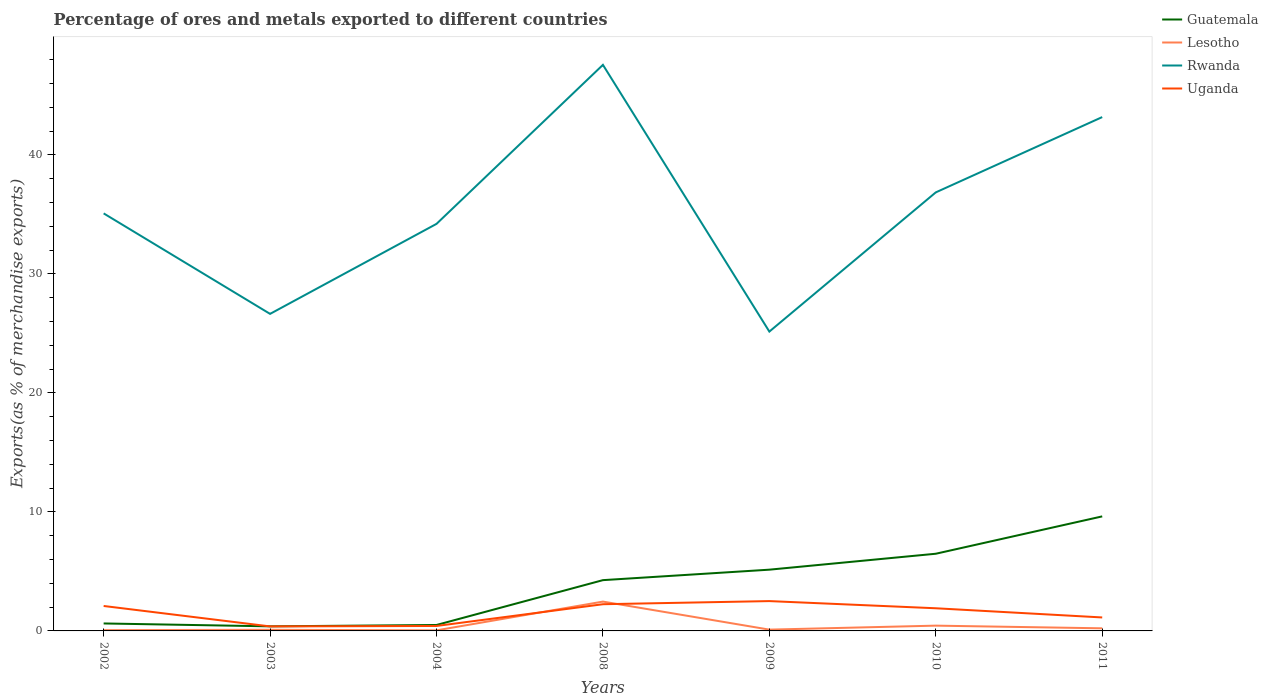Does the line corresponding to Rwanda intersect with the line corresponding to Guatemala?
Make the answer very short. No. Across all years, what is the maximum percentage of exports to different countries in Lesotho?
Offer a terse response. 0.05. In which year was the percentage of exports to different countries in Lesotho maximum?
Provide a succinct answer. 2004. What is the total percentage of exports to different countries in Lesotho in the graph?
Keep it short and to the point. -2.37. What is the difference between the highest and the second highest percentage of exports to different countries in Guatemala?
Your answer should be very brief. 9.24. What is the difference between the highest and the lowest percentage of exports to different countries in Rwanda?
Your answer should be compact. 3. Is the percentage of exports to different countries in Lesotho strictly greater than the percentage of exports to different countries in Guatemala over the years?
Your answer should be very brief. Yes. What is the difference between two consecutive major ticks on the Y-axis?
Offer a very short reply. 10. Are the values on the major ticks of Y-axis written in scientific E-notation?
Provide a succinct answer. No. How many legend labels are there?
Keep it short and to the point. 4. What is the title of the graph?
Make the answer very short. Percentage of ores and metals exported to different countries. What is the label or title of the Y-axis?
Offer a terse response. Exports(as % of merchandise exports). What is the Exports(as % of merchandise exports) in Guatemala in 2002?
Provide a succinct answer. 0.63. What is the Exports(as % of merchandise exports) of Lesotho in 2002?
Your response must be concise. 0.06. What is the Exports(as % of merchandise exports) of Rwanda in 2002?
Ensure brevity in your answer.  35.09. What is the Exports(as % of merchandise exports) of Uganda in 2002?
Give a very brief answer. 2.1. What is the Exports(as % of merchandise exports) in Guatemala in 2003?
Your answer should be very brief. 0.39. What is the Exports(as % of merchandise exports) in Lesotho in 2003?
Provide a succinct answer. 0.1. What is the Exports(as % of merchandise exports) in Rwanda in 2003?
Your answer should be very brief. 26.64. What is the Exports(as % of merchandise exports) in Uganda in 2003?
Give a very brief answer. 0.38. What is the Exports(as % of merchandise exports) of Guatemala in 2004?
Provide a succinct answer. 0.5. What is the Exports(as % of merchandise exports) in Lesotho in 2004?
Give a very brief answer. 0.05. What is the Exports(as % of merchandise exports) of Rwanda in 2004?
Give a very brief answer. 34.21. What is the Exports(as % of merchandise exports) of Uganda in 2004?
Your answer should be very brief. 0.42. What is the Exports(as % of merchandise exports) in Guatemala in 2008?
Your answer should be compact. 4.27. What is the Exports(as % of merchandise exports) in Lesotho in 2008?
Offer a terse response. 2.47. What is the Exports(as % of merchandise exports) of Rwanda in 2008?
Keep it short and to the point. 47.57. What is the Exports(as % of merchandise exports) of Uganda in 2008?
Provide a succinct answer. 2.24. What is the Exports(as % of merchandise exports) of Guatemala in 2009?
Provide a short and direct response. 5.15. What is the Exports(as % of merchandise exports) in Lesotho in 2009?
Provide a short and direct response. 0.11. What is the Exports(as % of merchandise exports) in Rwanda in 2009?
Offer a terse response. 25.16. What is the Exports(as % of merchandise exports) in Uganda in 2009?
Ensure brevity in your answer.  2.51. What is the Exports(as % of merchandise exports) in Guatemala in 2010?
Give a very brief answer. 6.49. What is the Exports(as % of merchandise exports) of Lesotho in 2010?
Your response must be concise. 0.44. What is the Exports(as % of merchandise exports) in Rwanda in 2010?
Your answer should be compact. 36.85. What is the Exports(as % of merchandise exports) in Uganda in 2010?
Ensure brevity in your answer.  1.9. What is the Exports(as % of merchandise exports) of Guatemala in 2011?
Give a very brief answer. 9.63. What is the Exports(as % of merchandise exports) of Lesotho in 2011?
Provide a succinct answer. 0.22. What is the Exports(as % of merchandise exports) in Rwanda in 2011?
Keep it short and to the point. 43.18. What is the Exports(as % of merchandise exports) of Uganda in 2011?
Make the answer very short. 1.13. Across all years, what is the maximum Exports(as % of merchandise exports) in Guatemala?
Your answer should be very brief. 9.63. Across all years, what is the maximum Exports(as % of merchandise exports) of Lesotho?
Provide a short and direct response. 2.47. Across all years, what is the maximum Exports(as % of merchandise exports) in Rwanda?
Offer a very short reply. 47.57. Across all years, what is the maximum Exports(as % of merchandise exports) in Uganda?
Make the answer very short. 2.51. Across all years, what is the minimum Exports(as % of merchandise exports) in Guatemala?
Your answer should be very brief. 0.39. Across all years, what is the minimum Exports(as % of merchandise exports) of Lesotho?
Provide a succinct answer. 0.05. Across all years, what is the minimum Exports(as % of merchandise exports) in Rwanda?
Provide a succinct answer. 25.16. Across all years, what is the minimum Exports(as % of merchandise exports) in Uganda?
Provide a succinct answer. 0.38. What is the total Exports(as % of merchandise exports) of Guatemala in the graph?
Make the answer very short. 27.04. What is the total Exports(as % of merchandise exports) of Lesotho in the graph?
Ensure brevity in your answer.  3.44. What is the total Exports(as % of merchandise exports) of Rwanda in the graph?
Your answer should be very brief. 248.7. What is the total Exports(as % of merchandise exports) of Uganda in the graph?
Your answer should be very brief. 10.68. What is the difference between the Exports(as % of merchandise exports) in Guatemala in 2002 and that in 2003?
Offer a very short reply. 0.24. What is the difference between the Exports(as % of merchandise exports) of Lesotho in 2002 and that in 2003?
Make the answer very short. -0.03. What is the difference between the Exports(as % of merchandise exports) in Rwanda in 2002 and that in 2003?
Your response must be concise. 8.45. What is the difference between the Exports(as % of merchandise exports) in Uganda in 2002 and that in 2003?
Offer a very short reply. 1.72. What is the difference between the Exports(as % of merchandise exports) of Guatemala in 2002 and that in 2004?
Make the answer very short. 0.13. What is the difference between the Exports(as % of merchandise exports) in Lesotho in 2002 and that in 2004?
Your response must be concise. 0.02. What is the difference between the Exports(as % of merchandise exports) in Rwanda in 2002 and that in 2004?
Provide a succinct answer. 0.88. What is the difference between the Exports(as % of merchandise exports) of Uganda in 2002 and that in 2004?
Make the answer very short. 1.68. What is the difference between the Exports(as % of merchandise exports) in Guatemala in 2002 and that in 2008?
Your answer should be compact. -3.64. What is the difference between the Exports(as % of merchandise exports) of Lesotho in 2002 and that in 2008?
Give a very brief answer. -2.4. What is the difference between the Exports(as % of merchandise exports) in Rwanda in 2002 and that in 2008?
Your response must be concise. -12.48. What is the difference between the Exports(as % of merchandise exports) of Uganda in 2002 and that in 2008?
Ensure brevity in your answer.  -0.15. What is the difference between the Exports(as % of merchandise exports) in Guatemala in 2002 and that in 2009?
Your answer should be compact. -4.52. What is the difference between the Exports(as % of merchandise exports) in Lesotho in 2002 and that in 2009?
Your answer should be compact. -0.04. What is the difference between the Exports(as % of merchandise exports) of Rwanda in 2002 and that in 2009?
Offer a terse response. 9.93. What is the difference between the Exports(as % of merchandise exports) in Uganda in 2002 and that in 2009?
Your answer should be compact. -0.41. What is the difference between the Exports(as % of merchandise exports) in Guatemala in 2002 and that in 2010?
Ensure brevity in your answer.  -5.86. What is the difference between the Exports(as % of merchandise exports) of Lesotho in 2002 and that in 2010?
Your answer should be very brief. -0.38. What is the difference between the Exports(as % of merchandise exports) of Rwanda in 2002 and that in 2010?
Your answer should be compact. -1.77. What is the difference between the Exports(as % of merchandise exports) of Uganda in 2002 and that in 2010?
Your response must be concise. 0.19. What is the difference between the Exports(as % of merchandise exports) of Guatemala in 2002 and that in 2011?
Offer a very short reply. -9. What is the difference between the Exports(as % of merchandise exports) of Lesotho in 2002 and that in 2011?
Ensure brevity in your answer.  -0.15. What is the difference between the Exports(as % of merchandise exports) of Rwanda in 2002 and that in 2011?
Ensure brevity in your answer.  -8.09. What is the difference between the Exports(as % of merchandise exports) in Uganda in 2002 and that in 2011?
Ensure brevity in your answer.  0.96. What is the difference between the Exports(as % of merchandise exports) in Guatemala in 2003 and that in 2004?
Your response must be concise. -0.11. What is the difference between the Exports(as % of merchandise exports) in Lesotho in 2003 and that in 2004?
Give a very brief answer. 0.05. What is the difference between the Exports(as % of merchandise exports) in Rwanda in 2003 and that in 2004?
Give a very brief answer. -7.56. What is the difference between the Exports(as % of merchandise exports) in Uganda in 2003 and that in 2004?
Your answer should be very brief. -0.04. What is the difference between the Exports(as % of merchandise exports) of Guatemala in 2003 and that in 2008?
Ensure brevity in your answer.  -3.88. What is the difference between the Exports(as % of merchandise exports) in Lesotho in 2003 and that in 2008?
Offer a terse response. -2.37. What is the difference between the Exports(as % of merchandise exports) of Rwanda in 2003 and that in 2008?
Provide a succinct answer. -20.93. What is the difference between the Exports(as % of merchandise exports) of Uganda in 2003 and that in 2008?
Your answer should be compact. -1.86. What is the difference between the Exports(as % of merchandise exports) of Guatemala in 2003 and that in 2009?
Your answer should be compact. -4.76. What is the difference between the Exports(as % of merchandise exports) of Lesotho in 2003 and that in 2009?
Provide a short and direct response. -0.01. What is the difference between the Exports(as % of merchandise exports) of Rwanda in 2003 and that in 2009?
Keep it short and to the point. 1.49. What is the difference between the Exports(as % of merchandise exports) in Uganda in 2003 and that in 2009?
Make the answer very short. -2.13. What is the difference between the Exports(as % of merchandise exports) in Guatemala in 2003 and that in 2010?
Your answer should be very brief. -6.1. What is the difference between the Exports(as % of merchandise exports) in Lesotho in 2003 and that in 2010?
Your answer should be very brief. -0.35. What is the difference between the Exports(as % of merchandise exports) in Rwanda in 2003 and that in 2010?
Provide a succinct answer. -10.21. What is the difference between the Exports(as % of merchandise exports) in Uganda in 2003 and that in 2010?
Offer a very short reply. -1.52. What is the difference between the Exports(as % of merchandise exports) in Guatemala in 2003 and that in 2011?
Offer a very short reply. -9.24. What is the difference between the Exports(as % of merchandise exports) of Lesotho in 2003 and that in 2011?
Your answer should be compact. -0.12. What is the difference between the Exports(as % of merchandise exports) of Rwanda in 2003 and that in 2011?
Ensure brevity in your answer.  -16.54. What is the difference between the Exports(as % of merchandise exports) of Uganda in 2003 and that in 2011?
Provide a short and direct response. -0.75. What is the difference between the Exports(as % of merchandise exports) in Guatemala in 2004 and that in 2008?
Provide a succinct answer. -3.77. What is the difference between the Exports(as % of merchandise exports) in Lesotho in 2004 and that in 2008?
Your answer should be very brief. -2.42. What is the difference between the Exports(as % of merchandise exports) of Rwanda in 2004 and that in 2008?
Your answer should be very brief. -13.36. What is the difference between the Exports(as % of merchandise exports) in Uganda in 2004 and that in 2008?
Your answer should be compact. -1.83. What is the difference between the Exports(as % of merchandise exports) in Guatemala in 2004 and that in 2009?
Your answer should be very brief. -4.65. What is the difference between the Exports(as % of merchandise exports) in Lesotho in 2004 and that in 2009?
Offer a terse response. -0.06. What is the difference between the Exports(as % of merchandise exports) in Rwanda in 2004 and that in 2009?
Provide a short and direct response. 9.05. What is the difference between the Exports(as % of merchandise exports) in Uganda in 2004 and that in 2009?
Provide a short and direct response. -2.09. What is the difference between the Exports(as % of merchandise exports) of Guatemala in 2004 and that in 2010?
Provide a succinct answer. -5.99. What is the difference between the Exports(as % of merchandise exports) in Lesotho in 2004 and that in 2010?
Your answer should be very brief. -0.4. What is the difference between the Exports(as % of merchandise exports) of Rwanda in 2004 and that in 2010?
Offer a terse response. -2.65. What is the difference between the Exports(as % of merchandise exports) in Uganda in 2004 and that in 2010?
Provide a short and direct response. -1.49. What is the difference between the Exports(as % of merchandise exports) of Guatemala in 2004 and that in 2011?
Ensure brevity in your answer.  -9.13. What is the difference between the Exports(as % of merchandise exports) in Lesotho in 2004 and that in 2011?
Make the answer very short. -0.17. What is the difference between the Exports(as % of merchandise exports) in Rwanda in 2004 and that in 2011?
Provide a succinct answer. -8.98. What is the difference between the Exports(as % of merchandise exports) of Uganda in 2004 and that in 2011?
Provide a succinct answer. -0.72. What is the difference between the Exports(as % of merchandise exports) of Guatemala in 2008 and that in 2009?
Your response must be concise. -0.88. What is the difference between the Exports(as % of merchandise exports) of Lesotho in 2008 and that in 2009?
Offer a very short reply. 2.36. What is the difference between the Exports(as % of merchandise exports) in Rwanda in 2008 and that in 2009?
Your answer should be compact. 22.41. What is the difference between the Exports(as % of merchandise exports) in Uganda in 2008 and that in 2009?
Your answer should be very brief. -0.26. What is the difference between the Exports(as % of merchandise exports) in Guatemala in 2008 and that in 2010?
Provide a short and direct response. -2.22. What is the difference between the Exports(as % of merchandise exports) of Lesotho in 2008 and that in 2010?
Make the answer very short. 2.02. What is the difference between the Exports(as % of merchandise exports) in Rwanda in 2008 and that in 2010?
Your answer should be compact. 10.72. What is the difference between the Exports(as % of merchandise exports) in Uganda in 2008 and that in 2010?
Keep it short and to the point. 0.34. What is the difference between the Exports(as % of merchandise exports) in Guatemala in 2008 and that in 2011?
Offer a terse response. -5.36. What is the difference between the Exports(as % of merchandise exports) of Lesotho in 2008 and that in 2011?
Ensure brevity in your answer.  2.25. What is the difference between the Exports(as % of merchandise exports) of Rwanda in 2008 and that in 2011?
Provide a succinct answer. 4.39. What is the difference between the Exports(as % of merchandise exports) in Uganda in 2008 and that in 2011?
Keep it short and to the point. 1.11. What is the difference between the Exports(as % of merchandise exports) of Guatemala in 2009 and that in 2010?
Make the answer very short. -1.34. What is the difference between the Exports(as % of merchandise exports) in Lesotho in 2009 and that in 2010?
Your answer should be very brief. -0.33. What is the difference between the Exports(as % of merchandise exports) in Rwanda in 2009 and that in 2010?
Your answer should be compact. -11.7. What is the difference between the Exports(as % of merchandise exports) in Uganda in 2009 and that in 2010?
Provide a succinct answer. 0.6. What is the difference between the Exports(as % of merchandise exports) of Guatemala in 2009 and that in 2011?
Your answer should be very brief. -4.48. What is the difference between the Exports(as % of merchandise exports) in Lesotho in 2009 and that in 2011?
Your answer should be very brief. -0.11. What is the difference between the Exports(as % of merchandise exports) of Rwanda in 2009 and that in 2011?
Keep it short and to the point. -18.03. What is the difference between the Exports(as % of merchandise exports) of Uganda in 2009 and that in 2011?
Ensure brevity in your answer.  1.37. What is the difference between the Exports(as % of merchandise exports) of Guatemala in 2010 and that in 2011?
Offer a terse response. -3.14. What is the difference between the Exports(as % of merchandise exports) of Lesotho in 2010 and that in 2011?
Ensure brevity in your answer.  0.22. What is the difference between the Exports(as % of merchandise exports) in Rwanda in 2010 and that in 2011?
Offer a very short reply. -6.33. What is the difference between the Exports(as % of merchandise exports) in Uganda in 2010 and that in 2011?
Ensure brevity in your answer.  0.77. What is the difference between the Exports(as % of merchandise exports) of Guatemala in 2002 and the Exports(as % of merchandise exports) of Lesotho in 2003?
Ensure brevity in your answer.  0.53. What is the difference between the Exports(as % of merchandise exports) of Guatemala in 2002 and the Exports(as % of merchandise exports) of Rwanda in 2003?
Offer a terse response. -26.01. What is the difference between the Exports(as % of merchandise exports) of Guatemala in 2002 and the Exports(as % of merchandise exports) of Uganda in 2003?
Provide a short and direct response. 0.25. What is the difference between the Exports(as % of merchandise exports) in Lesotho in 2002 and the Exports(as % of merchandise exports) in Rwanda in 2003?
Ensure brevity in your answer.  -26.58. What is the difference between the Exports(as % of merchandise exports) in Lesotho in 2002 and the Exports(as % of merchandise exports) in Uganda in 2003?
Provide a short and direct response. -0.31. What is the difference between the Exports(as % of merchandise exports) in Rwanda in 2002 and the Exports(as % of merchandise exports) in Uganda in 2003?
Make the answer very short. 34.71. What is the difference between the Exports(as % of merchandise exports) of Guatemala in 2002 and the Exports(as % of merchandise exports) of Lesotho in 2004?
Give a very brief answer. 0.58. What is the difference between the Exports(as % of merchandise exports) of Guatemala in 2002 and the Exports(as % of merchandise exports) of Rwanda in 2004?
Provide a succinct answer. -33.58. What is the difference between the Exports(as % of merchandise exports) in Guatemala in 2002 and the Exports(as % of merchandise exports) in Uganda in 2004?
Keep it short and to the point. 0.21. What is the difference between the Exports(as % of merchandise exports) of Lesotho in 2002 and the Exports(as % of merchandise exports) of Rwanda in 2004?
Keep it short and to the point. -34.14. What is the difference between the Exports(as % of merchandise exports) of Lesotho in 2002 and the Exports(as % of merchandise exports) of Uganda in 2004?
Keep it short and to the point. -0.35. What is the difference between the Exports(as % of merchandise exports) of Rwanda in 2002 and the Exports(as % of merchandise exports) of Uganda in 2004?
Your response must be concise. 34.67. What is the difference between the Exports(as % of merchandise exports) in Guatemala in 2002 and the Exports(as % of merchandise exports) in Lesotho in 2008?
Your answer should be compact. -1.84. What is the difference between the Exports(as % of merchandise exports) of Guatemala in 2002 and the Exports(as % of merchandise exports) of Rwanda in 2008?
Make the answer very short. -46.94. What is the difference between the Exports(as % of merchandise exports) in Guatemala in 2002 and the Exports(as % of merchandise exports) in Uganda in 2008?
Your answer should be compact. -1.62. What is the difference between the Exports(as % of merchandise exports) in Lesotho in 2002 and the Exports(as % of merchandise exports) in Rwanda in 2008?
Your response must be concise. -47.51. What is the difference between the Exports(as % of merchandise exports) of Lesotho in 2002 and the Exports(as % of merchandise exports) of Uganda in 2008?
Give a very brief answer. -2.18. What is the difference between the Exports(as % of merchandise exports) in Rwanda in 2002 and the Exports(as % of merchandise exports) in Uganda in 2008?
Your response must be concise. 32.84. What is the difference between the Exports(as % of merchandise exports) of Guatemala in 2002 and the Exports(as % of merchandise exports) of Lesotho in 2009?
Ensure brevity in your answer.  0.52. What is the difference between the Exports(as % of merchandise exports) in Guatemala in 2002 and the Exports(as % of merchandise exports) in Rwanda in 2009?
Offer a terse response. -24.53. What is the difference between the Exports(as % of merchandise exports) in Guatemala in 2002 and the Exports(as % of merchandise exports) in Uganda in 2009?
Your answer should be compact. -1.88. What is the difference between the Exports(as % of merchandise exports) in Lesotho in 2002 and the Exports(as % of merchandise exports) in Rwanda in 2009?
Offer a very short reply. -25.09. What is the difference between the Exports(as % of merchandise exports) of Lesotho in 2002 and the Exports(as % of merchandise exports) of Uganda in 2009?
Provide a succinct answer. -2.44. What is the difference between the Exports(as % of merchandise exports) of Rwanda in 2002 and the Exports(as % of merchandise exports) of Uganda in 2009?
Provide a short and direct response. 32.58. What is the difference between the Exports(as % of merchandise exports) in Guatemala in 2002 and the Exports(as % of merchandise exports) in Lesotho in 2010?
Your answer should be very brief. 0.18. What is the difference between the Exports(as % of merchandise exports) in Guatemala in 2002 and the Exports(as % of merchandise exports) in Rwanda in 2010?
Make the answer very short. -36.23. What is the difference between the Exports(as % of merchandise exports) of Guatemala in 2002 and the Exports(as % of merchandise exports) of Uganda in 2010?
Your response must be concise. -1.28. What is the difference between the Exports(as % of merchandise exports) of Lesotho in 2002 and the Exports(as % of merchandise exports) of Rwanda in 2010?
Offer a very short reply. -36.79. What is the difference between the Exports(as % of merchandise exports) of Lesotho in 2002 and the Exports(as % of merchandise exports) of Uganda in 2010?
Your answer should be very brief. -1.84. What is the difference between the Exports(as % of merchandise exports) in Rwanda in 2002 and the Exports(as % of merchandise exports) in Uganda in 2010?
Offer a very short reply. 33.18. What is the difference between the Exports(as % of merchandise exports) of Guatemala in 2002 and the Exports(as % of merchandise exports) of Lesotho in 2011?
Provide a succinct answer. 0.41. What is the difference between the Exports(as % of merchandise exports) of Guatemala in 2002 and the Exports(as % of merchandise exports) of Rwanda in 2011?
Your answer should be very brief. -42.55. What is the difference between the Exports(as % of merchandise exports) of Guatemala in 2002 and the Exports(as % of merchandise exports) of Uganda in 2011?
Provide a short and direct response. -0.5. What is the difference between the Exports(as % of merchandise exports) of Lesotho in 2002 and the Exports(as % of merchandise exports) of Rwanda in 2011?
Your response must be concise. -43.12. What is the difference between the Exports(as % of merchandise exports) of Lesotho in 2002 and the Exports(as % of merchandise exports) of Uganda in 2011?
Ensure brevity in your answer.  -1.07. What is the difference between the Exports(as % of merchandise exports) of Rwanda in 2002 and the Exports(as % of merchandise exports) of Uganda in 2011?
Your answer should be very brief. 33.96. What is the difference between the Exports(as % of merchandise exports) of Guatemala in 2003 and the Exports(as % of merchandise exports) of Lesotho in 2004?
Your answer should be compact. 0.34. What is the difference between the Exports(as % of merchandise exports) in Guatemala in 2003 and the Exports(as % of merchandise exports) in Rwanda in 2004?
Your response must be concise. -33.82. What is the difference between the Exports(as % of merchandise exports) of Guatemala in 2003 and the Exports(as % of merchandise exports) of Uganda in 2004?
Offer a very short reply. -0.03. What is the difference between the Exports(as % of merchandise exports) of Lesotho in 2003 and the Exports(as % of merchandise exports) of Rwanda in 2004?
Your answer should be very brief. -34.11. What is the difference between the Exports(as % of merchandise exports) of Lesotho in 2003 and the Exports(as % of merchandise exports) of Uganda in 2004?
Your answer should be very brief. -0.32. What is the difference between the Exports(as % of merchandise exports) of Rwanda in 2003 and the Exports(as % of merchandise exports) of Uganda in 2004?
Provide a succinct answer. 26.23. What is the difference between the Exports(as % of merchandise exports) of Guatemala in 2003 and the Exports(as % of merchandise exports) of Lesotho in 2008?
Provide a short and direct response. -2.08. What is the difference between the Exports(as % of merchandise exports) in Guatemala in 2003 and the Exports(as % of merchandise exports) in Rwanda in 2008?
Provide a succinct answer. -47.19. What is the difference between the Exports(as % of merchandise exports) of Guatemala in 2003 and the Exports(as % of merchandise exports) of Uganda in 2008?
Make the answer very short. -1.86. What is the difference between the Exports(as % of merchandise exports) of Lesotho in 2003 and the Exports(as % of merchandise exports) of Rwanda in 2008?
Your answer should be compact. -47.47. What is the difference between the Exports(as % of merchandise exports) of Lesotho in 2003 and the Exports(as % of merchandise exports) of Uganda in 2008?
Offer a terse response. -2.15. What is the difference between the Exports(as % of merchandise exports) in Rwanda in 2003 and the Exports(as % of merchandise exports) in Uganda in 2008?
Your response must be concise. 24.4. What is the difference between the Exports(as % of merchandise exports) in Guatemala in 2003 and the Exports(as % of merchandise exports) in Lesotho in 2009?
Provide a succinct answer. 0.28. What is the difference between the Exports(as % of merchandise exports) of Guatemala in 2003 and the Exports(as % of merchandise exports) of Rwanda in 2009?
Make the answer very short. -24.77. What is the difference between the Exports(as % of merchandise exports) in Guatemala in 2003 and the Exports(as % of merchandise exports) in Uganda in 2009?
Offer a very short reply. -2.12. What is the difference between the Exports(as % of merchandise exports) in Lesotho in 2003 and the Exports(as % of merchandise exports) in Rwanda in 2009?
Keep it short and to the point. -25.06. What is the difference between the Exports(as % of merchandise exports) in Lesotho in 2003 and the Exports(as % of merchandise exports) in Uganda in 2009?
Provide a short and direct response. -2.41. What is the difference between the Exports(as % of merchandise exports) in Rwanda in 2003 and the Exports(as % of merchandise exports) in Uganda in 2009?
Offer a very short reply. 24.14. What is the difference between the Exports(as % of merchandise exports) in Guatemala in 2003 and the Exports(as % of merchandise exports) in Lesotho in 2010?
Provide a succinct answer. -0.06. What is the difference between the Exports(as % of merchandise exports) of Guatemala in 2003 and the Exports(as % of merchandise exports) of Rwanda in 2010?
Your answer should be compact. -36.47. What is the difference between the Exports(as % of merchandise exports) in Guatemala in 2003 and the Exports(as % of merchandise exports) in Uganda in 2010?
Your answer should be compact. -1.52. What is the difference between the Exports(as % of merchandise exports) of Lesotho in 2003 and the Exports(as % of merchandise exports) of Rwanda in 2010?
Your response must be concise. -36.76. What is the difference between the Exports(as % of merchandise exports) in Lesotho in 2003 and the Exports(as % of merchandise exports) in Uganda in 2010?
Provide a succinct answer. -1.81. What is the difference between the Exports(as % of merchandise exports) of Rwanda in 2003 and the Exports(as % of merchandise exports) of Uganda in 2010?
Give a very brief answer. 24.74. What is the difference between the Exports(as % of merchandise exports) in Guatemala in 2003 and the Exports(as % of merchandise exports) in Lesotho in 2011?
Provide a short and direct response. 0.17. What is the difference between the Exports(as % of merchandise exports) in Guatemala in 2003 and the Exports(as % of merchandise exports) in Rwanda in 2011?
Make the answer very short. -42.8. What is the difference between the Exports(as % of merchandise exports) of Guatemala in 2003 and the Exports(as % of merchandise exports) of Uganda in 2011?
Keep it short and to the point. -0.75. What is the difference between the Exports(as % of merchandise exports) of Lesotho in 2003 and the Exports(as % of merchandise exports) of Rwanda in 2011?
Keep it short and to the point. -43.08. What is the difference between the Exports(as % of merchandise exports) in Lesotho in 2003 and the Exports(as % of merchandise exports) in Uganda in 2011?
Ensure brevity in your answer.  -1.04. What is the difference between the Exports(as % of merchandise exports) of Rwanda in 2003 and the Exports(as % of merchandise exports) of Uganda in 2011?
Provide a succinct answer. 25.51. What is the difference between the Exports(as % of merchandise exports) in Guatemala in 2004 and the Exports(as % of merchandise exports) in Lesotho in 2008?
Your answer should be compact. -1.97. What is the difference between the Exports(as % of merchandise exports) in Guatemala in 2004 and the Exports(as % of merchandise exports) in Rwanda in 2008?
Give a very brief answer. -47.07. What is the difference between the Exports(as % of merchandise exports) of Guatemala in 2004 and the Exports(as % of merchandise exports) of Uganda in 2008?
Provide a succinct answer. -1.74. What is the difference between the Exports(as % of merchandise exports) of Lesotho in 2004 and the Exports(as % of merchandise exports) of Rwanda in 2008?
Keep it short and to the point. -47.52. What is the difference between the Exports(as % of merchandise exports) of Lesotho in 2004 and the Exports(as % of merchandise exports) of Uganda in 2008?
Offer a very short reply. -2.2. What is the difference between the Exports(as % of merchandise exports) of Rwanda in 2004 and the Exports(as % of merchandise exports) of Uganda in 2008?
Your answer should be very brief. 31.96. What is the difference between the Exports(as % of merchandise exports) in Guatemala in 2004 and the Exports(as % of merchandise exports) in Lesotho in 2009?
Ensure brevity in your answer.  0.39. What is the difference between the Exports(as % of merchandise exports) of Guatemala in 2004 and the Exports(as % of merchandise exports) of Rwanda in 2009?
Offer a very short reply. -24.66. What is the difference between the Exports(as % of merchandise exports) in Guatemala in 2004 and the Exports(as % of merchandise exports) in Uganda in 2009?
Provide a succinct answer. -2.01. What is the difference between the Exports(as % of merchandise exports) in Lesotho in 2004 and the Exports(as % of merchandise exports) in Rwanda in 2009?
Keep it short and to the point. -25.11. What is the difference between the Exports(as % of merchandise exports) in Lesotho in 2004 and the Exports(as % of merchandise exports) in Uganda in 2009?
Provide a succinct answer. -2.46. What is the difference between the Exports(as % of merchandise exports) of Rwanda in 2004 and the Exports(as % of merchandise exports) of Uganda in 2009?
Your answer should be compact. 31.7. What is the difference between the Exports(as % of merchandise exports) in Guatemala in 2004 and the Exports(as % of merchandise exports) in Lesotho in 2010?
Your response must be concise. 0.06. What is the difference between the Exports(as % of merchandise exports) of Guatemala in 2004 and the Exports(as % of merchandise exports) of Rwanda in 2010?
Provide a short and direct response. -36.35. What is the difference between the Exports(as % of merchandise exports) of Guatemala in 2004 and the Exports(as % of merchandise exports) of Uganda in 2010?
Give a very brief answer. -1.41. What is the difference between the Exports(as % of merchandise exports) of Lesotho in 2004 and the Exports(as % of merchandise exports) of Rwanda in 2010?
Your response must be concise. -36.81. What is the difference between the Exports(as % of merchandise exports) in Lesotho in 2004 and the Exports(as % of merchandise exports) in Uganda in 2010?
Keep it short and to the point. -1.86. What is the difference between the Exports(as % of merchandise exports) in Rwanda in 2004 and the Exports(as % of merchandise exports) in Uganda in 2010?
Your answer should be very brief. 32.3. What is the difference between the Exports(as % of merchandise exports) of Guatemala in 2004 and the Exports(as % of merchandise exports) of Lesotho in 2011?
Provide a succinct answer. 0.28. What is the difference between the Exports(as % of merchandise exports) in Guatemala in 2004 and the Exports(as % of merchandise exports) in Rwanda in 2011?
Your response must be concise. -42.68. What is the difference between the Exports(as % of merchandise exports) of Guatemala in 2004 and the Exports(as % of merchandise exports) of Uganda in 2011?
Provide a short and direct response. -0.63. What is the difference between the Exports(as % of merchandise exports) in Lesotho in 2004 and the Exports(as % of merchandise exports) in Rwanda in 2011?
Your answer should be very brief. -43.13. What is the difference between the Exports(as % of merchandise exports) of Lesotho in 2004 and the Exports(as % of merchandise exports) of Uganda in 2011?
Provide a succinct answer. -1.08. What is the difference between the Exports(as % of merchandise exports) of Rwanda in 2004 and the Exports(as % of merchandise exports) of Uganda in 2011?
Provide a succinct answer. 33.07. What is the difference between the Exports(as % of merchandise exports) in Guatemala in 2008 and the Exports(as % of merchandise exports) in Lesotho in 2009?
Your answer should be compact. 4.16. What is the difference between the Exports(as % of merchandise exports) of Guatemala in 2008 and the Exports(as % of merchandise exports) of Rwanda in 2009?
Make the answer very short. -20.89. What is the difference between the Exports(as % of merchandise exports) of Guatemala in 2008 and the Exports(as % of merchandise exports) of Uganda in 2009?
Keep it short and to the point. 1.76. What is the difference between the Exports(as % of merchandise exports) of Lesotho in 2008 and the Exports(as % of merchandise exports) of Rwanda in 2009?
Keep it short and to the point. -22.69. What is the difference between the Exports(as % of merchandise exports) of Lesotho in 2008 and the Exports(as % of merchandise exports) of Uganda in 2009?
Your answer should be compact. -0.04. What is the difference between the Exports(as % of merchandise exports) of Rwanda in 2008 and the Exports(as % of merchandise exports) of Uganda in 2009?
Provide a succinct answer. 45.06. What is the difference between the Exports(as % of merchandise exports) of Guatemala in 2008 and the Exports(as % of merchandise exports) of Lesotho in 2010?
Your answer should be compact. 3.82. What is the difference between the Exports(as % of merchandise exports) in Guatemala in 2008 and the Exports(as % of merchandise exports) in Rwanda in 2010?
Your answer should be very brief. -32.59. What is the difference between the Exports(as % of merchandise exports) of Guatemala in 2008 and the Exports(as % of merchandise exports) of Uganda in 2010?
Ensure brevity in your answer.  2.36. What is the difference between the Exports(as % of merchandise exports) of Lesotho in 2008 and the Exports(as % of merchandise exports) of Rwanda in 2010?
Ensure brevity in your answer.  -34.39. What is the difference between the Exports(as % of merchandise exports) in Lesotho in 2008 and the Exports(as % of merchandise exports) in Uganda in 2010?
Keep it short and to the point. 0.56. What is the difference between the Exports(as % of merchandise exports) in Rwanda in 2008 and the Exports(as % of merchandise exports) in Uganda in 2010?
Offer a terse response. 45.67. What is the difference between the Exports(as % of merchandise exports) of Guatemala in 2008 and the Exports(as % of merchandise exports) of Lesotho in 2011?
Your response must be concise. 4.05. What is the difference between the Exports(as % of merchandise exports) of Guatemala in 2008 and the Exports(as % of merchandise exports) of Rwanda in 2011?
Give a very brief answer. -38.91. What is the difference between the Exports(as % of merchandise exports) of Guatemala in 2008 and the Exports(as % of merchandise exports) of Uganda in 2011?
Provide a succinct answer. 3.14. What is the difference between the Exports(as % of merchandise exports) in Lesotho in 2008 and the Exports(as % of merchandise exports) in Rwanda in 2011?
Make the answer very short. -40.72. What is the difference between the Exports(as % of merchandise exports) of Lesotho in 2008 and the Exports(as % of merchandise exports) of Uganda in 2011?
Give a very brief answer. 1.33. What is the difference between the Exports(as % of merchandise exports) in Rwanda in 2008 and the Exports(as % of merchandise exports) in Uganda in 2011?
Give a very brief answer. 46.44. What is the difference between the Exports(as % of merchandise exports) of Guatemala in 2009 and the Exports(as % of merchandise exports) of Lesotho in 2010?
Keep it short and to the point. 4.7. What is the difference between the Exports(as % of merchandise exports) in Guatemala in 2009 and the Exports(as % of merchandise exports) in Rwanda in 2010?
Offer a terse response. -31.71. What is the difference between the Exports(as % of merchandise exports) of Guatemala in 2009 and the Exports(as % of merchandise exports) of Uganda in 2010?
Your response must be concise. 3.24. What is the difference between the Exports(as % of merchandise exports) of Lesotho in 2009 and the Exports(as % of merchandise exports) of Rwanda in 2010?
Your response must be concise. -36.74. What is the difference between the Exports(as % of merchandise exports) in Lesotho in 2009 and the Exports(as % of merchandise exports) in Uganda in 2010?
Your answer should be compact. -1.8. What is the difference between the Exports(as % of merchandise exports) in Rwanda in 2009 and the Exports(as % of merchandise exports) in Uganda in 2010?
Ensure brevity in your answer.  23.25. What is the difference between the Exports(as % of merchandise exports) of Guatemala in 2009 and the Exports(as % of merchandise exports) of Lesotho in 2011?
Give a very brief answer. 4.93. What is the difference between the Exports(as % of merchandise exports) in Guatemala in 2009 and the Exports(as % of merchandise exports) in Rwanda in 2011?
Your answer should be compact. -38.03. What is the difference between the Exports(as % of merchandise exports) of Guatemala in 2009 and the Exports(as % of merchandise exports) of Uganda in 2011?
Make the answer very short. 4.02. What is the difference between the Exports(as % of merchandise exports) of Lesotho in 2009 and the Exports(as % of merchandise exports) of Rwanda in 2011?
Make the answer very short. -43.07. What is the difference between the Exports(as % of merchandise exports) of Lesotho in 2009 and the Exports(as % of merchandise exports) of Uganda in 2011?
Offer a very short reply. -1.02. What is the difference between the Exports(as % of merchandise exports) in Rwanda in 2009 and the Exports(as % of merchandise exports) in Uganda in 2011?
Provide a succinct answer. 24.02. What is the difference between the Exports(as % of merchandise exports) in Guatemala in 2010 and the Exports(as % of merchandise exports) in Lesotho in 2011?
Give a very brief answer. 6.27. What is the difference between the Exports(as % of merchandise exports) of Guatemala in 2010 and the Exports(as % of merchandise exports) of Rwanda in 2011?
Offer a terse response. -36.69. What is the difference between the Exports(as % of merchandise exports) of Guatemala in 2010 and the Exports(as % of merchandise exports) of Uganda in 2011?
Offer a terse response. 5.35. What is the difference between the Exports(as % of merchandise exports) in Lesotho in 2010 and the Exports(as % of merchandise exports) in Rwanda in 2011?
Provide a short and direct response. -42.74. What is the difference between the Exports(as % of merchandise exports) in Lesotho in 2010 and the Exports(as % of merchandise exports) in Uganda in 2011?
Your answer should be compact. -0.69. What is the difference between the Exports(as % of merchandise exports) in Rwanda in 2010 and the Exports(as % of merchandise exports) in Uganda in 2011?
Your answer should be very brief. 35.72. What is the average Exports(as % of merchandise exports) in Guatemala per year?
Offer a very short reply. 3.86. What is the average Exports(as % of merchandise exports) of Lesotho per year?
Keep it short and to the point. 0.49. What is the average Exports(as % of merchandise exports) of Rwanda per year?
Provide a short and direct response. 35.53. What is the average Exports(as % of merchandise exports) in Uganda per year?
Provide a short and direct response. 1.53. In the year 2002, what is the difference between the Exports(as % of merchandise exports) of Guatemala and Exports(as % of merchandise exports) of Lesotho?
Your answer should be compact. 0.56. In the year 2002, what is the difference between the Exports(as % of merchandise exports) of Guatemala and Exports(as % of merchandise exports) of Rwanda?
Keep it short and to the point. -34.46. In the year 2002, what is the difference between the Exports(as % of merchandise exports) in Guatemala and Exports(as % of merchandise exports) in Uganda?
Your response must be concise. -1.47. In the year 2002, what is the difference between the Exports(as % of merchandise exports) of Lesotho and Exports(as % of merchandise exports) of Rwanda?
Offer a very short reply. -35.02. In the year 2002, what is the difference between the Exports(as % of merchandise exports) in Lesotho and Exports(as % of merchandise exports) in Uganda?
Provide a short and direct response. -2.03. In the year 2002, what is the difference between the Exports(as % of merchandise exports) of Rwanda and Exports(as % of merchandise exports) of Uganda?
Offer a terse response. 32.99. In the year 2003, what is the difference between the Exports(as % of merchandise exports) in Guatemala and Exports(as % of merchandise exports) in Lesotho?
Ensure brevity in your answer.  0.29. In the year 2003, what is the difference between the Exports(as % of merchandise exports) in Guatemala and Exports(as % of merchandise exports) in Rwanda?
Provide a short and direct response. -26.26. In the year 2003, what is the difference between the Exports(as % of merchandise exports) in Guatemala and Exports(as % of merchandise exports) in Uganda?
Offer a terse response. 0.01. In the year 2003, what is the difference between the Exports(as % of merchandise exports) in Lesotho and Exports(as % of merchandise exports) in Rwanda?
Your answer should be very brief. -26.55. In the year 2003, what is the difference between the Exports(as % of merchandise exports) of Lesotho and Exports(as % of merchandise exports) of Uganda?
Your answer should be compact. -0.28. In the year 2003, what is the difference between the Exports(as % of merchandise exports) of Rwanda and Exports(as % of merchandise exports) of Uganda?
Offer a very short reply. 26.26. In the year 2004, what is the difference between the Exports(as % of merchandise exports) in Guatemala and Exports(as % of merchandise exports) in Lesotho?
Ensure brevity in your answer.  0.45. In the year 2004, what is the difference between the Exports(as % of merchandise exports) of Guatemala and Exports(as % of merchandise exports) of Rwanda?
Offer a terse response. -33.71. In the year 2004, what is the difference between the Exports(as % of merchandise exports) of Guatemala and Exports(as % of merchandise exports) of Uganda?
Provide a succinct answer. 0.08. In the year 2004, what is the difference between the Exports(as % of merchandise exports) in Lesotho and Exports(as % of merchandise exports) in Rwanda?
Ensure brevity in your answer.  -34.16. In the year 2004, what is the difference between the Exports(as % of merchandise exports) of Lesotho and Exports(as % of merchandise exports) of Uganda?
Offer a very short reply. -0.37. In the year 2004, what is the difference between the Exports(as % of merchandise exports) of Rwanda and Exports(as % of merchandise exports) of Uganda?
Offer a very short reply. 33.79. In the year 2008, what is the difference between the Exports(as % of merchandise exports) of Guatemala and Exports(as % of merchandise exports) of Lesotho?
Offer a terse response. 1.8. In the year 2008, what is the difference between the Exports(as % of merchandise exports) of Guatemala and Exports(as % of merchandise exports) of Rwanda?
Make the answer very short. -43.3. In the year 2008, what is the difference between the Exports(as % of merchandise exports) in Guatemala and Exports(as % of merchandise exports) in Uganda?
Offer a very short reply. 2.02. In the year 2008, what is the difference between the Exports(as % of merchandise exports) in Lesotho and Exports(as % of merchandise exports) in Rwanda?
Your response must be concise. -45.11. In the year 2008, what is the difference between the Exports(as % of merchandise exports) in Lesotho and Exports(as % of merchandise exports) in Uganda?
Give a very brief answer. 0.22. In the year 2008, what is the difference between the Exports(as % of merchandise exports) in Rwanda and Exports(as % of merchandise exports) in Uganda?
Offer a terse response. 45.33. In the year 2009, what is the difference between the Exports(as % of merchandise exports) of Guatemala and Exports(as % of merchandise exports) of Lesotho?
Offer a terse response. 5.04. In the year 2009, what is the difference between the Exports(as % of merchandise exports) of Guatemala and Exports(as % of merchandise exports) of Rwanda?
Keep it short and to the point. -20.01. In the year 2009, what is the difference between the Exports(as % of merchandise exports) in Guatemala and Exports(as % of merchandise exports) in Uganda?
Give a very brief answer. 2.64. In the year 2009, what is the difference between the Exports(as % of merchandise exports) in Lesotho and Exports(as % of merchandise exports) in Rwanda?
Keep it short and to the point. -25.05. In the year 2009, what is the difference between the Exports(as % of merchandise exports) of Lesotho and Exports(as % of merchandise exports) of Uganda?
Keep it short and to the point. -2.4. In the year 2009, what is the difference between the Exports(as % of merchandise exports) of Rwanda and Exports(as % of merchandise exports) of Uganda?
Ensure brevity in your answer.  22.65. In the year 2010, what is the difference between the Exports(as % of merchandise exports) of Guatemala and Exports(as % of merchandise exports) of Lesotho?
Offer a very short reply. 6.04. In the year 2010, what is the difference between the Exports(as % of merchandise exports) of Guatemala and Exports(as % of merchandise exports) of Rwanda?
Make the answer very short. -30.37. In the year 2010, what is the difference between the Exports(as % of merchandise exports) of Guatemala and Exports(as % of merchandise exports) of Uganda?
Ensure brevity in your answer.  4.58. In the year 2010, what is the difference between the Exports(as % of merchandise exports) in Lesotho and Exports(as % of merchandise exports) in Rwanda?
Your answer should be very brief. -36.41. In the year 2010, what is the difference between the Exports(as % of merchandise exports) of Lesotho and Exports(as % of merchandise exports) of Uganda?
Provide a succinct answer. -1.46. In the year 2010, what is the difference between the Exports(as % of merchandise exports) in Rwanda and Exports(as % of merchandise exports) in Uganda?
Your response must be concise. 34.95. In the year 2011, what is the difference between the Exports(as % of merchandise exports) in Guatemala and Exports(as % of merchandise exports) in Lesotho?
Offer a very short reply. 9.41. In the year 2011, what is the difference between the Exports(as % of merchandise exports) in Guatemala and Exports(as % of merchandise exports) in Rwanda?
Ensure brevity in your answer.  -33.55. In the year 2011, what is the difference between the Exports(as % of merchandise exports) of Guatemala and Exports(as % of merchandise exports) of Uganda?
Ensure brevity in your answer.  8.49. In the year 2011, what is the difference between the Exports(as % of merchandise exports) in Lesotho and Exports(as % of merchandise exports) in Rwanda?
Keep it short and to the point. -42.96. In the year 2011, what is the difference between the Exports(as % of merchandise exports) in Lesotho and Exports(as % of merchandise exports) in Uganda?
Provide a short and direct response. -0.91. In the year 2011, what is the difference between the Exports(as % of merchandise exports) of Rwanda and Exports(as % of merchandise exports) of Uganda?
Provide a short and direct response. 42.05. What is the ratio of the Exports(as % of merchandise exports) in Guatemala in 2002 to that in 2003?
Give a very brief answer. 1.63. What is the ratio of the Exports(as % of merchandise exports) of Lesotho in 2002 to that in 2003?
Give a very brief answer. 0.67. What is the ratio of the Exports(as % of merchandise exports) in Rwanda in 2002 to that in 2003?
Your response must be concise. 1.32. What is the ratio of the Exports(as % of merchandise exports) in Uganda in 2002 to that in 2003?
Your response must be concise. 5.53. What is the ratio of the Exports(as % of merchandise exports) of Guatemala in 2002 to that in 2004?
Keep it short and to the point. 1.26. What is the ratio of the Exports(as % of merchandise exports) of Lesotho in 2002 to that in 2004?
Offer a very short reply. 1.36. What is the ratio of the Exports(as % of merchandise exports) in Rwanda in 2002 to that in 2004?
Offer a terse response. 1.03. What is the ratio of the Exports(as % of merchandise exports) in Uganda in 2002 to that in 2004?
Provide a succinct answer. 5.03. What is the ratio of the Exports(as % of merchandise exports) in Guatemala in 2002 to that in 2008?
Your response must be concise. 0.15. What is the ratio of the Exports(as % of merchandise exports) in Lesotho in 2002 to that in 2008?
Make the answer very short. 0.03. What is the ratio of the Exports(as % of merchandise exports) of Rwanda in 2002 to that in 2008?
Offer a very short reply. 0.74. What is the ratio of the Exports(as % of merchandise exports) in Uganda in 2002 to that in 2008?
Your response must be concise. 0.93. What is the ratio of the Exports(as % of merchandise exports) of Guatemala in 2002 to that in 2009?
Your answer should be compact. 0.12. What is the ratio of the Exports(as % of merchandise exports) in Lesotho in 2002 to that in 2009?
Offer a terse response. 0.59. What is the ratio of the Exports(as % of merchandise exports) in Rwanda in 2002 to that in 2009?
Offer a terse response. 1.39. What is the ratio of the Exports(as % of merchandise exports) in Uganda in 2002 to that in 2009?
Provide a succinct answer. 0.84. What is the ratio of the Exports(as % of merchandise exports) of Guatemala in 2002 to that in 2010?
Offer a terse response. 0.1. What is the ratio of the Exports(as % of merchandise exports) in Lesotho in 2002 to that in 2010?
Provide a short and direct response. 0.15. What is the ratio of the Exports(as % of merchandise exports) of Rwanda in 2002 to that in 2010?
Make the answer very short. 0.95. What is the ratio of the Exports(as % of merchandise exports) in Uganda in 2002 to that in 2010?
Offer a terse response. 1.1. What is the ratio of the Exports(as % of merchandise exports) of Guatemala in 2002 to that in 2011?
Provide a succinct answer. 0.07. What is the ratio of the Exports(as % of merchandise exports) of Lesotho in 2002 to that in 2011?
Provide a succinct answer. 0.29. What is the ratio of the Exports(as % of merchandise exports) in Rwanda in 2002 to that in 2011?
Your response must be concise. 0.81. What is the ratio of the Exports(as % of merchandise exports) in Uganda in 2002 to that in 2011?
Offer a terse response. 1.85. What is the ratio of the Exports(as % of merchandise exports) of Guatemala in 2003 to that in 2004?
Your response must be concise. 0.77. What is the ratio of the Exports(as % of merchandise exports) of Lesotho in 2003 to that in 2004?
Ensure brevity in your answer.  2.05. What is the ratio of the Exports(as % of merchandise exports) in Rwanda in 2003 to that in 2004?
Ensure brevity in your answer.  0.78. What is the ratio of the Exports(as % of merchandise exports) in Uganda in 2003 to that in 2004?
Ensure brevity in your answer.  0.91. What is the ratio of the Exports(as % of merchandise exports) in Guatemala in 2003 to that in 2008?
Provide a succinct answer. 0.09. What is the ratio of the Exports(as % of merchandise exports) in Lesotho in 2003 to that in 2008?
Your answer should be compact. 0.04. What is the ratio of the Exports(as % of merchandise exports) of Rwanda in 2003 to that in 2008?
Your response must be concise. 0.56. What is the ratio of the Exports(as % of merchandise exports) of Uganda in 2003 to that in 2008?
Your answer should be compact. 0.17. What is the ratio of the Exports(as % of merchandise exports) in Guatemala in 2003 to that in 2009?
Ensure brevity in your answer.  0.07. What is the ratio of the Exports(as % of merchandise exports) of Lesotho in 2003 to that in 2009?
Your response must be concise. 0.89. What is the ratio of the Exports(as % of merchandise exports) of Rwanda in 2003 to that in 2009?
Provide a short and direct response. 1.06. What is the ratio of the Exports(as % of merchandise exports) in Uganda in 2003 to that in 2009?
Keep it short and to the point. 0.15. What is the ratio of the Exports(as % of merchandise exports) in Guatemala in 2003 to that in 2010?
Provide a succinct answer. 0.06. What is the ratio of the Exports(as % of merchandise exports) of Lesotho in 2003 to that in 2010?
Provide a short and direct response. 0.22. What is the ratio of the Exports(as % of merchandise exports) in Rwanda in 2003 to that in 2010?
Ensure brevity in your answer.  0.72. What is the ratio of the Exports(as % of merchandise exports) of Uganda in 2003 to that in 2010?
Provide a succinct answer. 0.2. What is the ratio of the Exports(as % of merchandise exports) of Lesotho in 2003 to that in 2011?
Provide a succinct answer. 0.44. What is the ratio of the Exports(as % of merchandise exports) in Rwanda in 2003 to that in 2011?
Offer a terse response. 0.62. What is the ratio of the Exports(as % of merchandise exports) of Uganda in 2003 to that in 2011?
Your answer should be very brief. 0.34. What is the ratio of the Exports(as % of merchandise exports) of Guatemala in 2004 to that in 2008?
Your answer should be compact. 0.12. What is the ratio of the Exports(as % of merchandise exports) in Lesotho in 2004 to that in 2008?
Your answer should be very brief. 0.02. What is the ratio of the Exports(as % of merchandise exports) in Rwanda in 2004 to that in 2008?
Your answer should be very brief. 0.72. What is the ratio of the Exports(as % of merchandise exports) in Uganda in 2004 to that in 2008?
Your answer should be compact. 0.19. What is the ratio of the Exports(as % of merchandise exports) in Guatemala in 2004 to that in 2009?
Keep it short and to the point. 0.1. What is the ratio of the Exports(as % of merchandise exports) in Lesotho in 2004 to that in 2009?
Provide a succinct answer. 0.43. What is the ratio of the Exports(as % of merchandise exports) in Rwanda in 2004 to that in 2009?
Provide a short and direct response. 1.36. What is the ratio of the Exports(as % of merchandise exports) in Uganda in 2004 to that in 2009?
Offer a terse response. 0.17. What is the ratio of the Exports(as % of merchandise exports) in Guatemala in 2004 to that in 2010?
Give a very brief answer. 0.08. What is the ratio of the Exports(as % of merchandise exports) in Lesotho in 2004 to that in 2010?
Offer a terse response. 0.11. What is the ratio of the Exports(as % of merchandise exports) of Rwanda in 2004 to that in 2010?
Provide a succinct answer. 0.93. What is the ratio of the Exports(as % of merchandise exports) of Uganda in 2004 to that in 2010?
Offer a terse response. 0.22. What is the ratio of the Exports(as % of merchandise exports) of Guatemala in 2004 to that in 2011?
Your response must be concise. 0.05. What is the ratio of the Exports(as % of merchandise exports) of Lesotho in 2004 to that in 2011?
Your answer should be very brief. 0.22. What is the ratio of the Exports(as % of merchandise exports) of Rwanda in 2004 to that in 2011?
Offer a terse response. 0.79. What is the ratio of the Exports(as % of merchandise exports) of Uganda in 2004 to that in 2011?
Offer a terse response. 0.37. What is the ratio of the Exports(as % of merchandise exports) of Guatemala in 2008 to that in 2009?
Keep it short and to the point. 0.83. What is the ratio of the Exports(as % of merchandise exports) of Lesotho in 2008 to that in 2009?
Offer a terse response. 22.62. What is the ratio of the Exports(as % of merchandise exports) in Rwanda in 2008 to that in 2009?
Offer a very short reply. 1.89. What is the ratio of the Exports(as % of merchandise exports) of Uganda in 2008 to that in 2009?
Your answer should be compact. 0.9. What is the ratio of the Exports(as % of merchandise exports) of Guatemala in 2008 to that in 2010?
Your response must be concise. 0.66. What is the ratio of the Exports(as % of merchandise exports) of Lesotho in 2008 to that in 2010?
Provide a short and direct response. 5.56. What is the ratio of the Exports(as % of merchandise exports) in Rwanda in 2008 to that in 2010?
Offer a terse response. 1.29. What is the ratio of the Exports(as % of merchandise exports) in Uganda in 2008 to that in 2010?
Offer a terse response. 1.18. What is the ratio of the Exports(as % of merchandise exports) in Guatemala in 2008 to that in 2011?
Your answer should be very brief. 0.44. What is the ratio of the Exports(as % of merchandise exports) of Lesotho in 2008 to that in 2011?
Give a very brief answer. 11.25. What is the ratio of the Exports(as % of merchandise exports) of Rwanda in 2008 to that in 2011?
Make the answer very short. 1.1. What is the ratio of the Exports(as % of merchandise exports) of Uganda in 2008 to that in 2011?
Provide a short and direct response. 1.98. What is the ratio of the Exports(as % of merchandise exports) of Guatemala in 2009 to that in 2010?
Your response must be concise. 0.79. What is the ratio of the Exports(as % of merchandise exports) in Lesotho in 2009 to that in 2010?
Provide a short and direct response. 0.25. What is the ratio of the Exports(as % of merchandise exports) of Rwanda in 2009 to that in 2010?
Offer a very short reply. 0.68. What is the ratio of the Exports(as % of merchandise exports) in Uganda in 2009 to that in 2010?
Provide a short and direct response. 1.32. What is the ratio of the Exports(as % of merchandise exports) in Guatemala in 2009 to that in 2011?
Offer a very short reply. 0.53. What is the ratio of the Exports(as % of merchandise exports) in Lesotho in 2009 to that in 2011?
Ensure brevity in your answer.  0.5. What is the ratio of the Exports(as % of merchandise exports) of Rwanda in 2009 to that in 2011?
Provide a short and direct response. 0.58. What is the ratio of the Exports(as % of merchandise exports) of Uganda in 2009 to that in 2011?
Give a very brief answer. 2.21. What is the ratio of the Exports(as % of merchandise exports) in Guatemala in 2010 to that in 2011?
Your answer should be very brief. 0.67. What is the ratio of the Exports(as % of merchandise exports) in Lesotho in 2010 to that in 2011?
Your response must be concise. 2.02. What is the ratio of the Exports(as % of merchandise exports) in Rwanda in 2010 to that in 2011?
Give a very brief answer. 0.85. What is the ratio of the Exports(as % of merchandise exports) in Uganda in 2010 to that in 2011?
Offer a terse response. 1.68. What is the difference between the highest and the second highest Exports(as % of merchandise exports) in Guatemala?
Your answer should be very brief. 3.14. What is the difference between the highest and the second highest Exports(as % of merchandise exports) in Lesotho?
Make the answer very short. 2.02. What is the difference between the highest and the second highest Exports(as % of merchandise exports) in Rwanda?
Provide a short and direct response. 4.39. What is the difference between the highest and the second highest Exports(as % of merchandise exports) in Uganda?
Give a very brief answer. 0.26. What is the difference between the highest and the lowest Exports(as % of merchandise exports) of Guatemala?
Make the answer very short. 9.24. What is the difference between the highest and the lowest Exports(as % of merchandise exports) in Lesotho?
Give a very brief answer. 2.42. What is the difference between the highest and the lowest Exports(as % of merchandise exports) of Rwanda?
Your answer should be very brief. 22.41. What is the difference between the highest and the lowest Exports(as % of merchandise exports) of Uganda?
Provide a short and direct response. 2.13. 